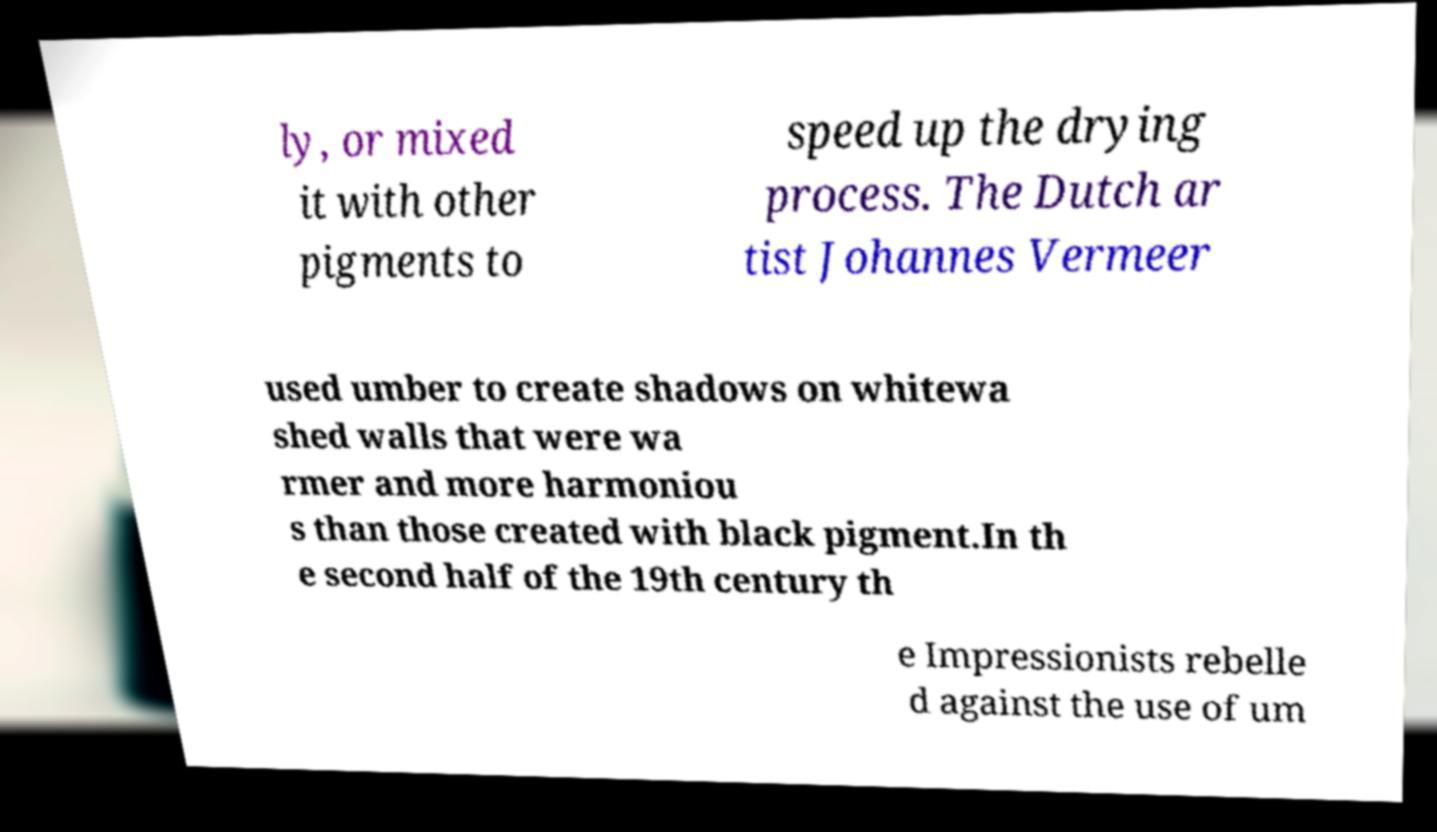Please read and relay the text visible in this image. What does it say? ly, or mixed it with other pigments to speed up the drying process. The Dutch ar tist Johannes Vermeer used umber to create shadows on whitewa shed walls that were wa rmer and more harmoniou s than those created with black pigment.In th e second half of the 19th century th e Impressionists rebelle d against the use of um 